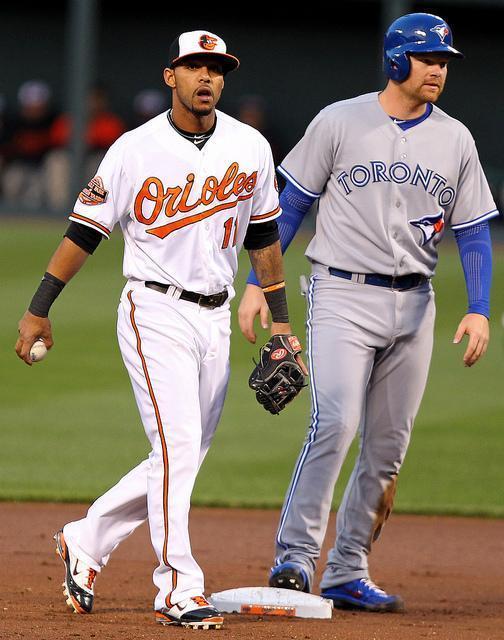How many players are wearing a helmet?
Give a very brief answer. 1. How many people are there?
Give a very brief answer. 3. How many bikes are behind the clock?
Give a very brief answer. 0. 